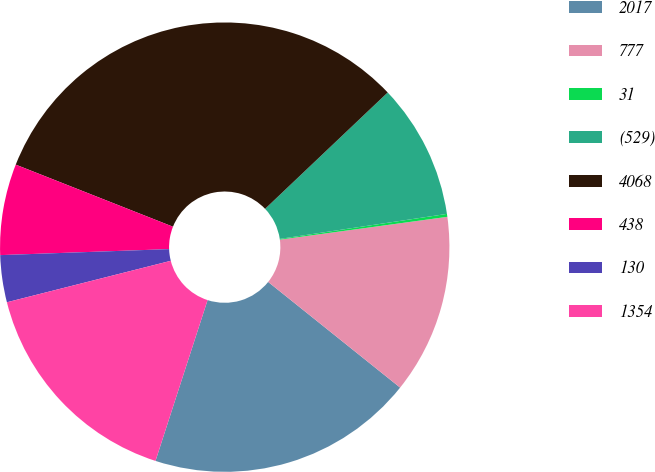Convert chart. <chart><loc_0><loc_0><loc_500><loc_500><pie_chart><fcel>2017<fcel>777<fcel>31<fcel>(529)<fcel>4068<fcel>438<fcel>130<fcel>1354<nl><fcel>19.24%<fcel>12.9%<fcel>0.21%<fcel>9.72%<fcel>31.93%<fcel>6.55%<fcel>3.38%<fcel>16.07%<nl></chart> 